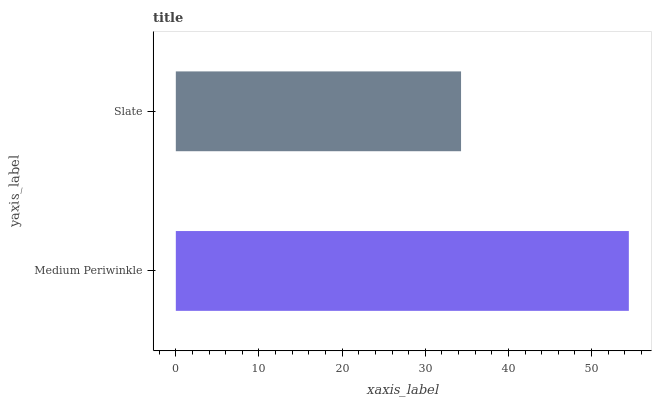Is Slate the minimum?
Answer yes or no. Yes. Is Medium Periwinkle the maximum?
Answer yes or no. Yes. Is Slate the maximum?
Answer yes or no. No. Is Medium Periwinkle greater than Slate?
Answer yes or no. Yes. Is Slate less than Medium Periwinkle?
Answer yes or no. Yes. Is Slate greater than Medium Periwinkle?
Answer yes or no. No. Is Medium Periwinkle less than Slate?
Answer yes or no. No. Is Medium Periwinkle the high median?
Answer yes or no. Yes. Is Slate the low median?
Answer yes or no. Yes. Is Slate the high median?
Answer yes or no. No. Is Medium Periwinkle the low median?
Answer yes or no. No. 